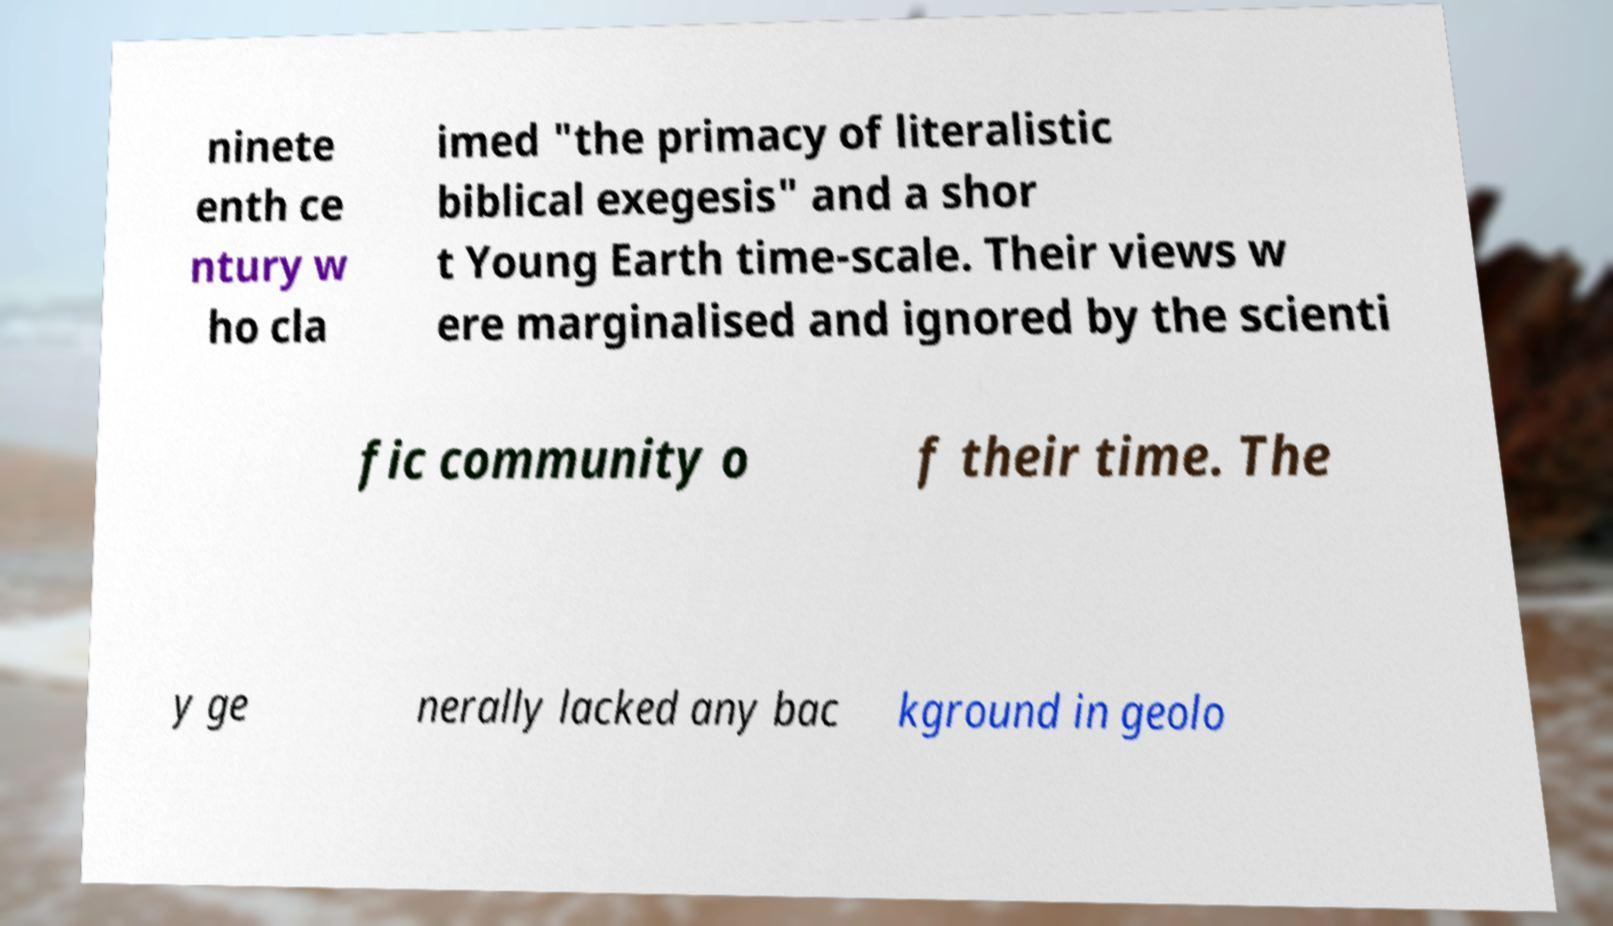I need the written content from this picture converted into text. Can you do that? ninete enth ce ntury w ho cla imed "the primacy of literalistic biblical exegesis" and a shor t Young Earth time-scale. Their views w ere marginalised and ignored by the scienti fic community o f their time. The y ge nerally lacked any bac kground in geolo 